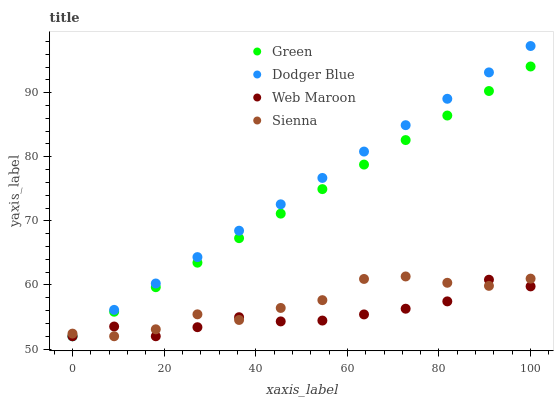Does Web Maroon have the minimum area under the curve?
Answer yes or no. Yes. Does Dodger Blue have the maximum area under the curve?
Answer yes or no. Yes. Does Green have the minimum area under the curve?
Answer yes or no. No. Does Green have the maximum area under the curve?
Answer yes or no. No. Is Dodger Blue the smoothest?
Answer yes or no. Yes. Is Sienna the roughest?
Answer yes or no. Yes. Is Green the smoothest?
Answer yes or no. No. Is Green the roughest?
Answer yes or no. No. Does Sienna have the lowest value?
Answer yes or no. Yes. Does Dodger Blue have the highest value?
Answer yes or no. Yes. Does Green have the highest value?
Answer yes or no. No. Does Dodger Blue intersect Web Maroon?
Answer yes or no. Yes. Is Dodger Blue less than Web Maroon?
Answer yes or no. No. Is Dodger Blue greater than Web Maroon?
Answer yes or no. No. 